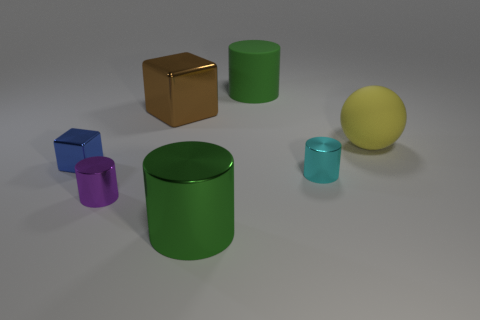Subtract all purple cylinders. How many cylinders are left? 3 Add 3 tiny purple metallic cylinders. How many objects exist? 10 Subtract all brown cubes. How many cubes are left? 1 Subtract 1 spheres. How many spheres are left? 0 Subtract 1 yellow spheres. How many objects are left? 6 Subtract all spheres. How many objects are left? 6 Subtract all gray cylinders. Subtract all brown spheres. How many cylinders are left? 4 Subtract all green balls. How many purple cylinders are left? 1 Subtract all small cyan shiny things. Subtract all blue blocks. How many objects are left? 5 Add 6 rubber objects. How many rubber objects are left? 8 